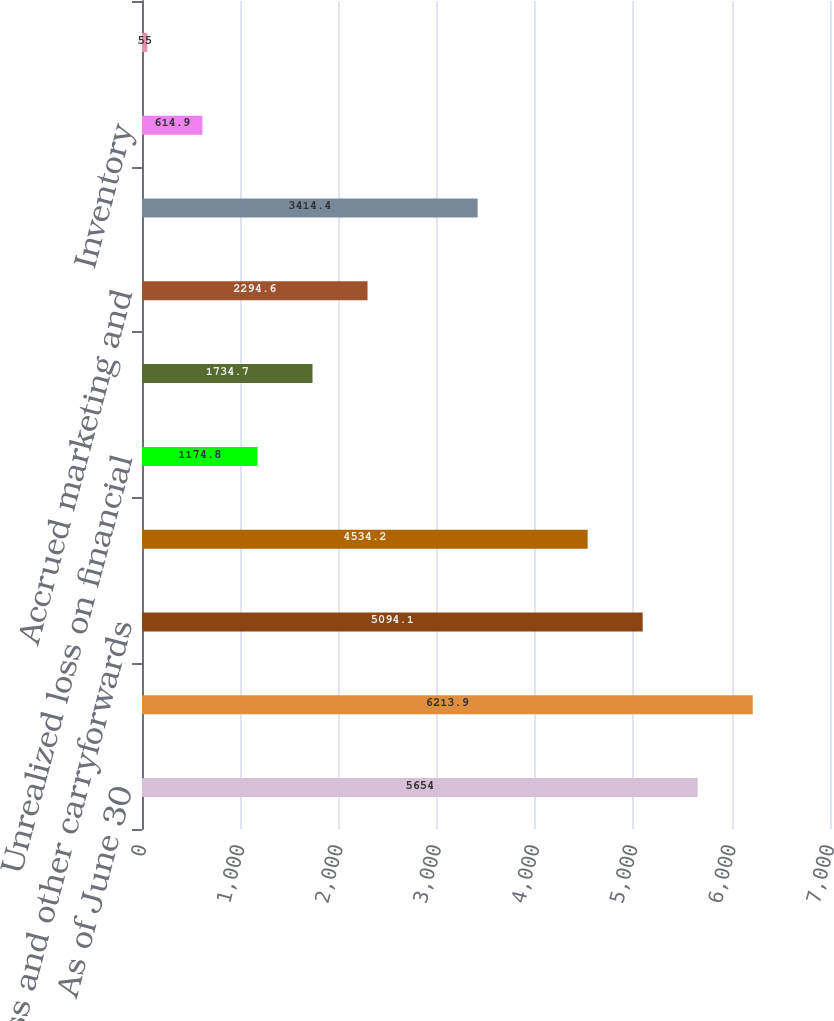<chart> <loc_0><loc_0><loc_500><loc_500><bar_chart><fcel>As of June 30<fcel>Pension and postretirement<fcel>Loss and other carryforwards<fcel>Stock-based compensation<fcel>Unrealized loss on financial<fcel>Fixed assets<fcel>Accrued marketing and<fcel>Advance payments<fcel>Inventory<fcel>Accrued interest and taxes<nl><fcel>5654<fcel>6213.9<fcel>5094.1<fcel>4534.2<fcel>1174.8<fcel>1734.7<fcel>2294.6<fcel>3414.4<fcel>614.9<fcel>55<nl></chart> 